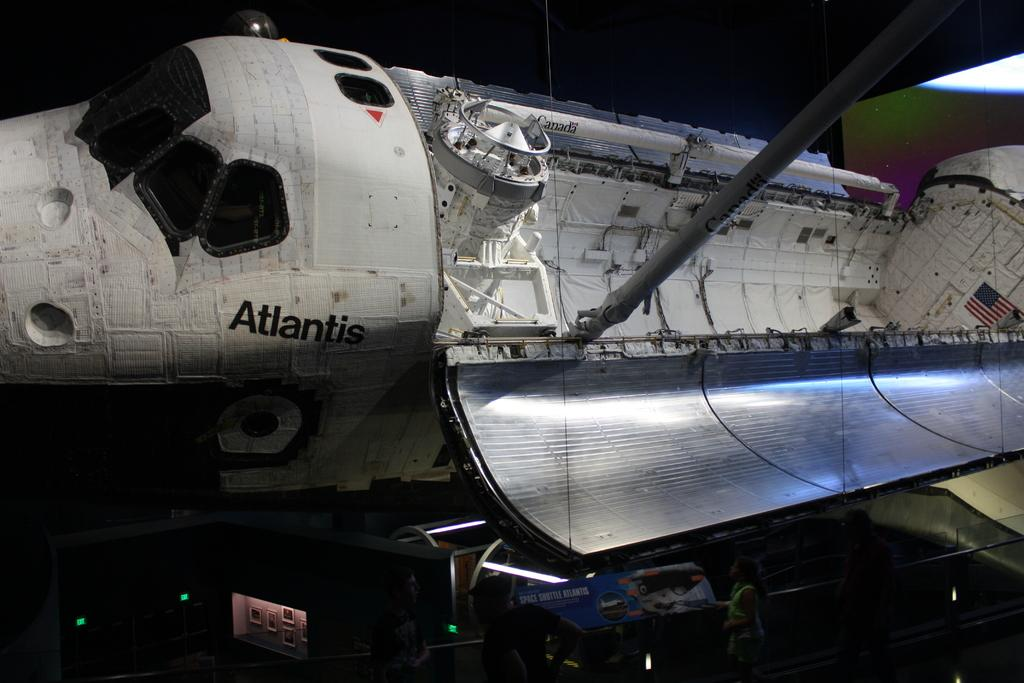What is the main subject of the image? The image depicts a space shuttle port. Are there any specific features or objects visible in the image? Yes, there are lights in the image. Can you describe any other elements in the image? There are unspecified "things" in the image. Is there any indication of human presence in the image? Yes, there is a person in the image. What type of scent can be detected in the image? There is no indication of a scent in the image, as it is a visual representation of a space shuttle port. Are there any signs of an attack in the image? There is no indication of an attack in the image; it appears to be a peaceful scene of a space shuttle port. 